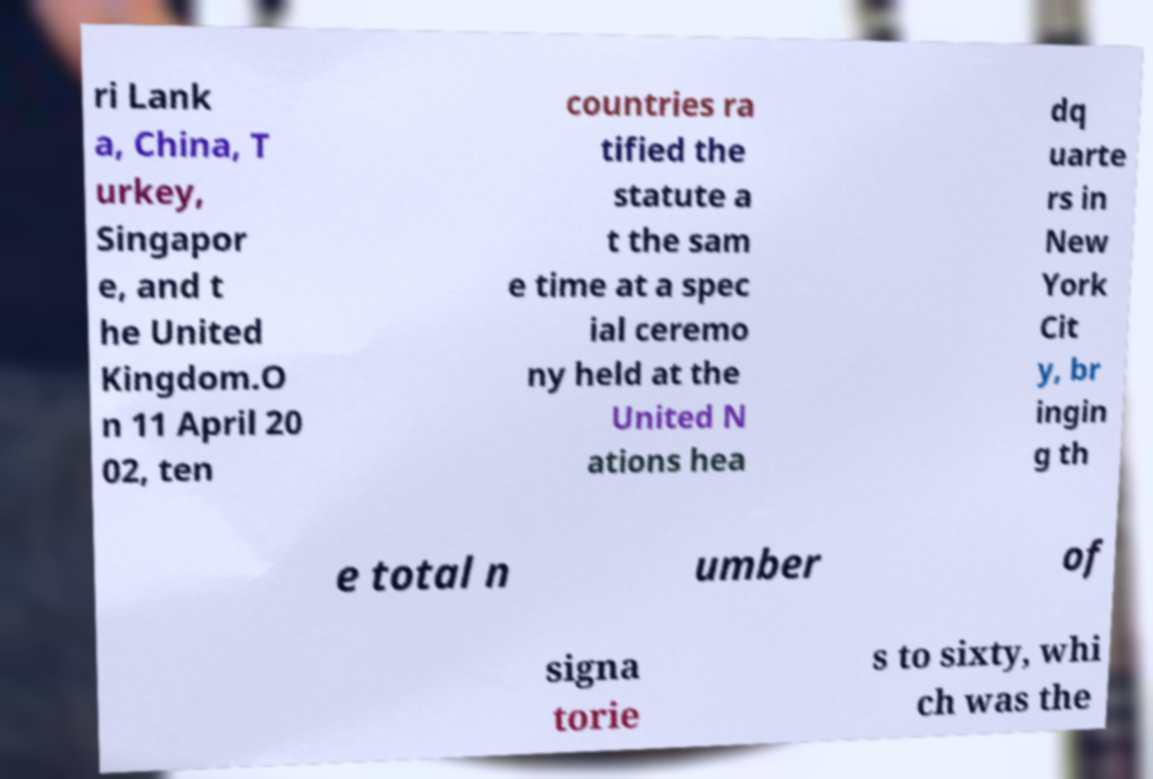Could you extract and type out the text from this image? ri Lank a, China, T urkey, Singapor e, and t he United Kingdom.O n 11 April 20 02, ten countries ra tified the statute a t the sam e time at a spec ial ceremo ny held at the United N ations hea dq uarte rs in New York Cit y, br ingin g th e total n umber of signa torie s to sixty, whi ch was the 